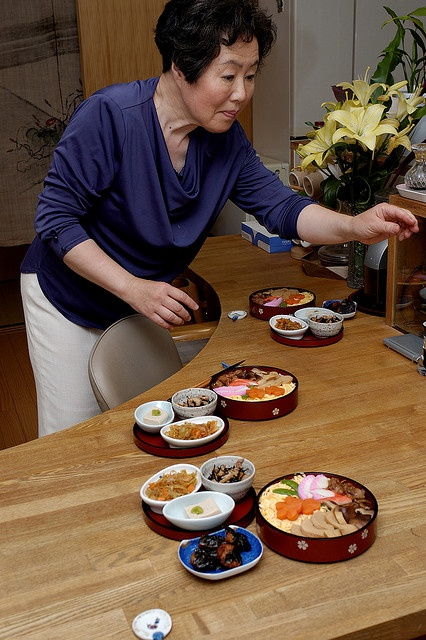Describe the objects in this image and their specific colors. I can see dining table in black, tan, olive, and maroon tones, people in black, navy, darkgray, and gray tones, potted plant in black, tan, gray, and olive tones, bowl in black, maroon, khaki, and tan tones, and chair in black, gray, and darkgray tones in this image. 